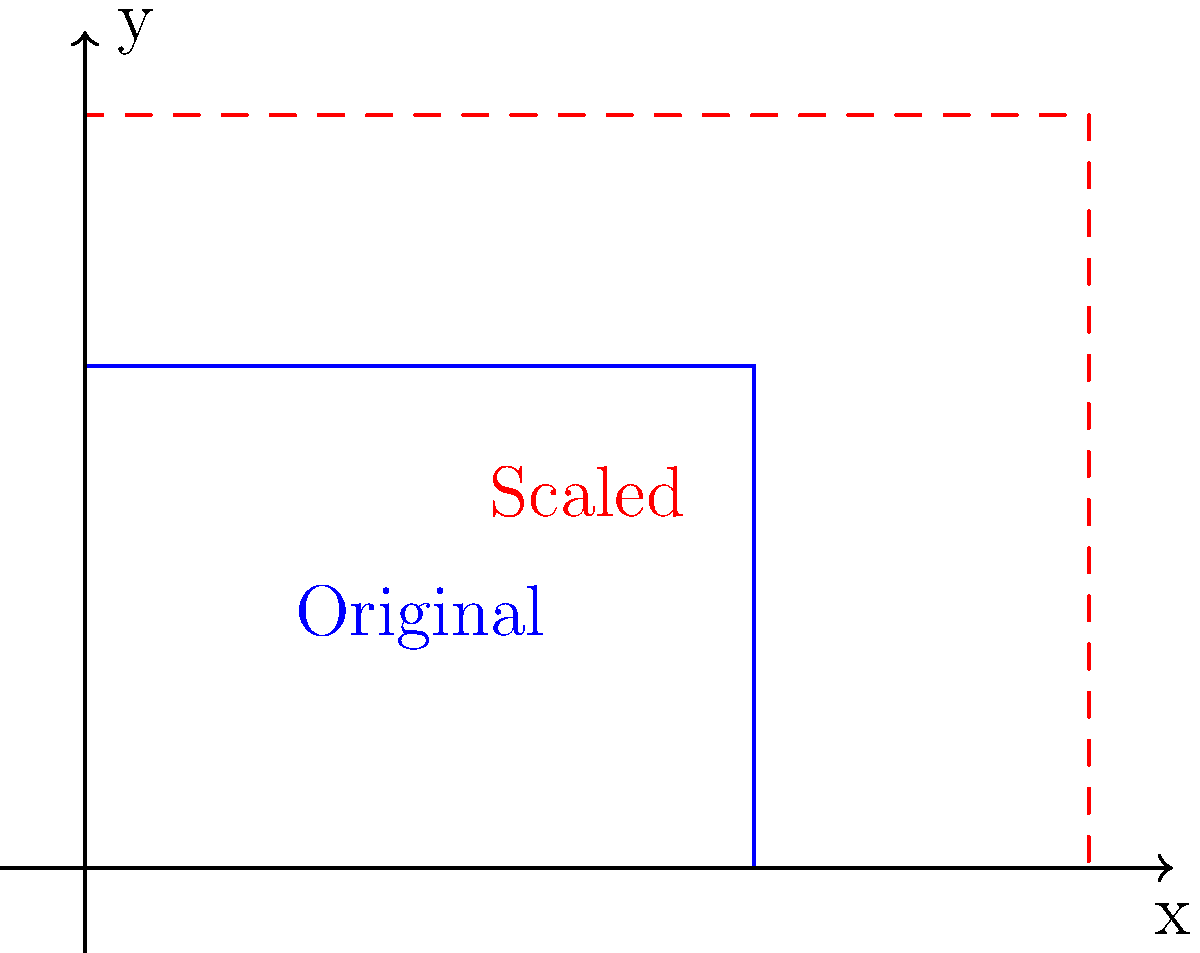A garment sketch for a petite size is represented by a rectangle with dimensions 4 units wide and 3 units tall. To adapt this design for a larger size, the sketch needs to be scaled up by a factor of 1.5. What are the dimensions of the scaled-up garment sketch, and what is the ratio of the new area to the original area? Let's approach this step-by-step:

1. Original dimensions:
   Width = 4 units
   Height = 3 units

2. Scaling factor = 1.5

3. New dimensions:
   New width = Original width × Scaling factor
              = 4 × 1.5 = 6 units
   
   New height = Original height × Scaling factor
               = 3 × 1.5 = 4.5 units

4. Areas:
   Original area = Width × Height = 4 × 3 = 12 square units
   
   New area = New width × New height = 6 × 4.5 = 27 square units

5. Ratio of new area to original area:
   Ratio = New area ÷ Original area
         = 27 ÷ 12
         = 2.25

This ratio can also be derived directly from the scaling factor:
   $(1.5)^2 = 2.25$

This is because when we scale both dimensions by 1.5, the area scales by $(1.5)^2$.
Answer: 6 units × 4.5 units; 2.25:1 